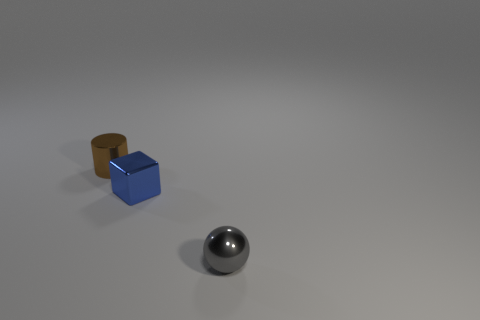Add 2 big brown blocks. How many objects exist? 5 Subtract all blocks. How many objects are left? 2 Add 3 spheres. How many spheres exist? 4 Subtract 0 purple cylinders. How many objects are left? 3 Subtract all small metal blocks. Subtract all tiny blue cubes. How many objects are left? 1 Add 2 blue metal objects. How many blue metal objects are left? 3 